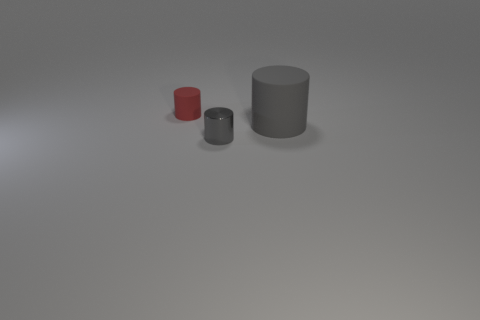Is the metal thing the same size as the red cylinder?
Ensure brevity in your answer.  Yes. Are there more tiny rubber objects right of the big gray object than metallic cylinders?
Keep it short and to the point. No. The gray object that is the same material as the red thing is what size?
Your answer should be compact. Large. There is a large matte object; are there any red matte things behind it?
Ensure brevity in your answer.  Yes. Is the shape of the gray metallic object the same as the red matte object?
Your answer should be very brief. Yes. What is the size of the gray object that is left of the rubber object that is right of the gray object that is in front of the big gray cylinder?
Offer a terse response. Small. What material is the big cylinder?
Make the answer very short. Rubber. What is the size of the cylinder that is the same color as the small shiny object?
Make the answer very short. Large. Is the shape of the gray metallic object the same as the rubber object that is in front of the small red rubber thing?
Keep it short and to the point. Yes. What is the material of the tiny thing that is in front of the thing to the right of the small thing that is to the right of the red object?
Provide a succinct answer. Metal. 